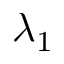Convert formula to latex. <formula><loc_0><loc_0><loc_500><loc_500>\lambda _ { 1 }</formula> 